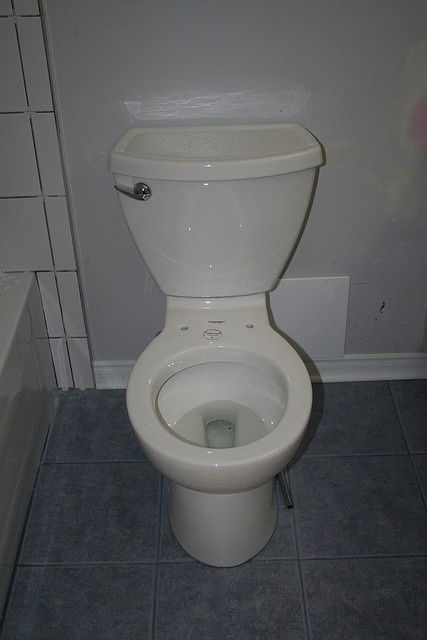Describe the objects in this image and their specific colors. I can see a toilet in gray and black tones in this image. 